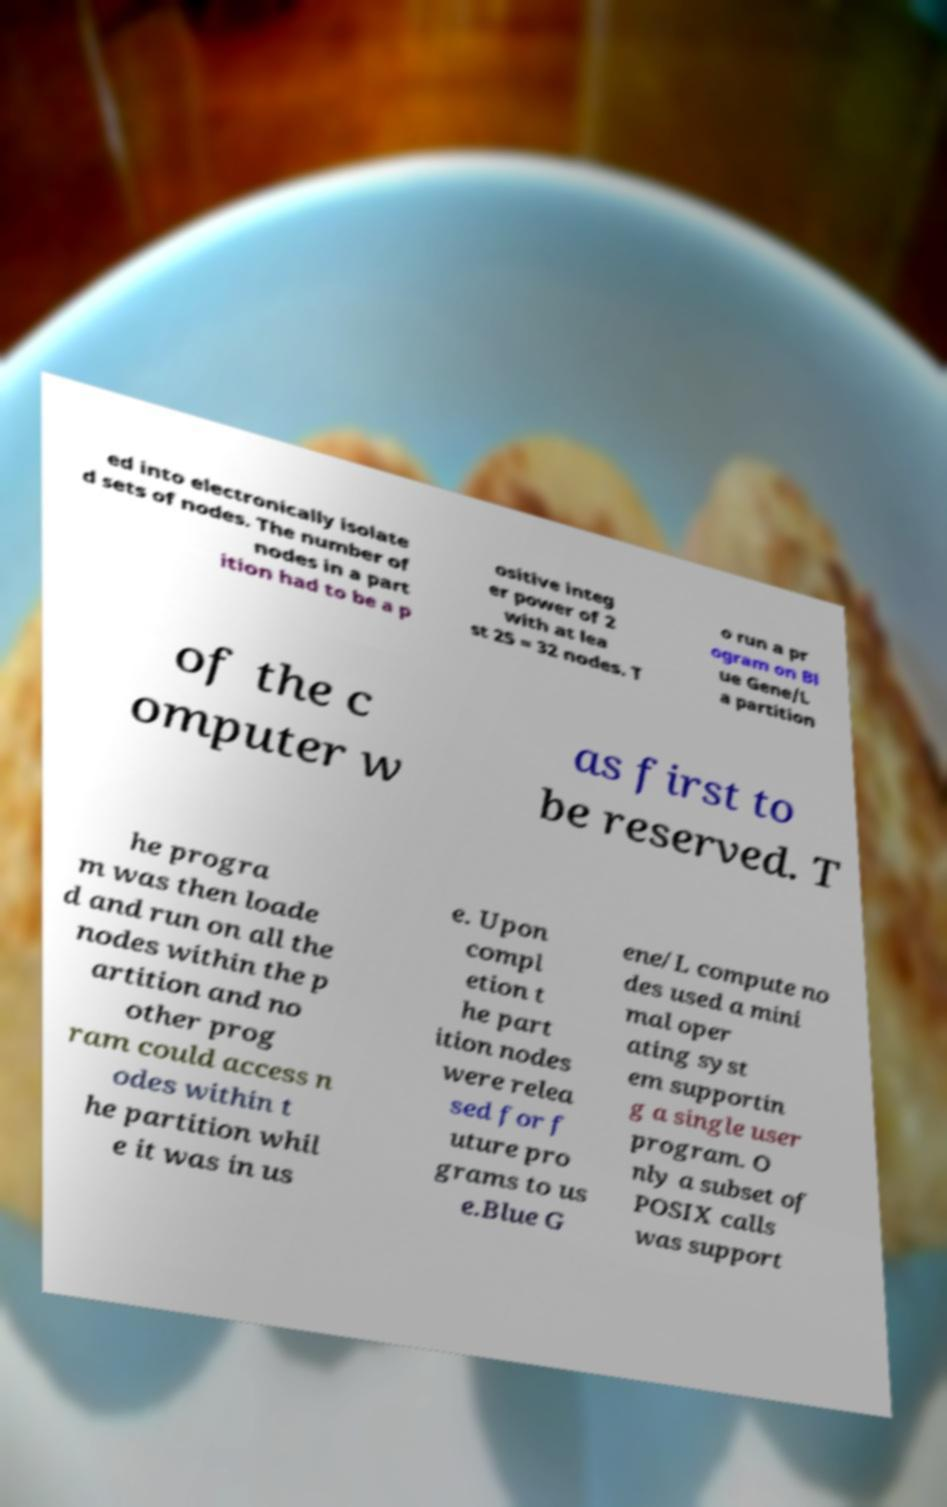Please read and relay the text visible in this image. What does it say? ed into electronically isolate d sets of nodes. The number of nodes in a part ition had to be a p ositive integ er power of 2 with at lea st 25 = 32 nodes. T o run a pr ogram on Bl ue Gene/L a partition of the c omputer w as first to be reserved. T he progra m was then loade d and run on all the nodes within the p artition and no other prog ram could access n odes within t he partition whil e it was in us e. Upon compl etion t he part ition nodes were relea sed for f uture pro grams to us e.Blue G ene/L compute no des used a mini mal oper ating syst em supportin g a single user program. O nly a subset of POSIX calls was support 